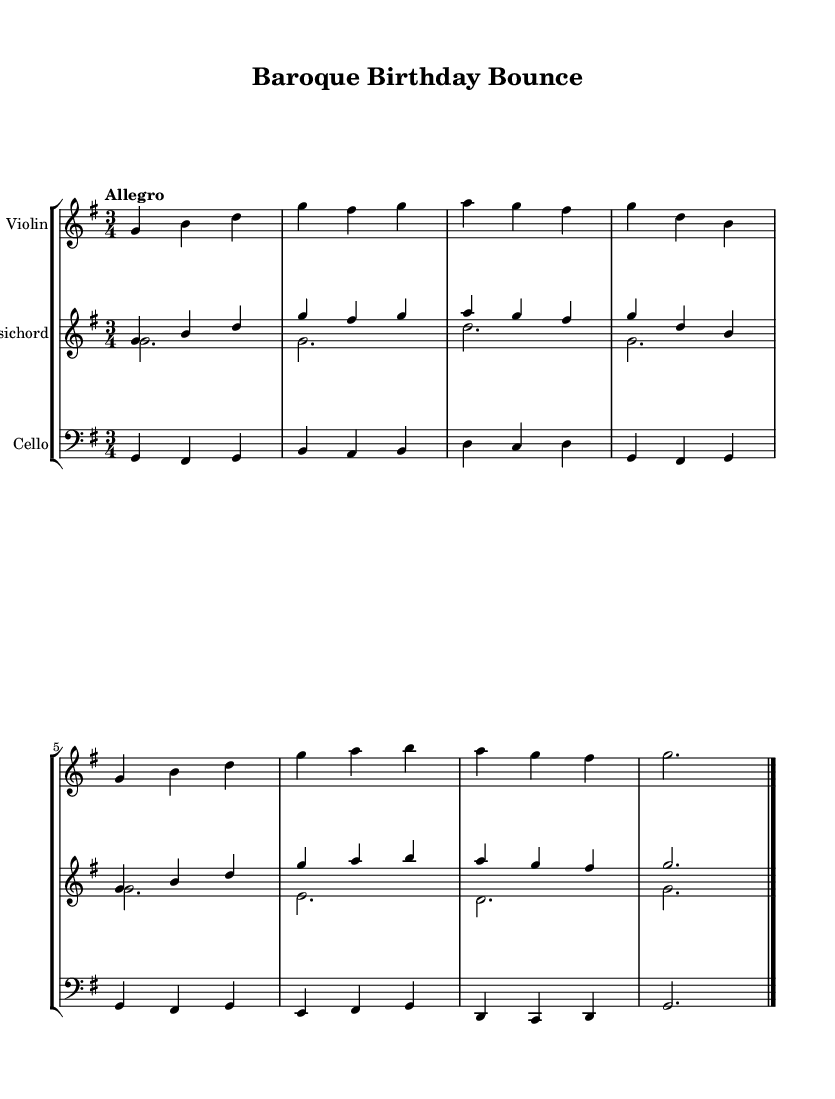What is the key signature of this music? The key signature is G major, which has one sharp (F#). This can be identified by looking at the key signature indicated at the beginning of the staff, which is located between the clef and the time signature.
Answer: G major What is the time signature of this music? The time signature is 3/4, signifying three beats per measure and a quarter note gets one beat. This is evident from the notation written after the key signature at the beginning of the piece.
Answer: 3/4 What is the tempo marking for the music? The tempo marking is "Allegro", suggesting a fast and lively pace. This indication is found near the start of the score, indicating how quickly the music should be played.
Answer: Allegro How many measures are there in the piece? There are eight measures in total. Counting the measures can be done by identifying the vertical lines that denote the end of each measure in the musical notation.
Answer: Eight Which instrument plays the melody? The violin plays the melody. This can be determined by observing that the violin staff is typically higher in pitch and the specific notes arranged for it outline the melodic line.
Answer: Violin What type of dance rhythm is characteristic of this music? The music features an upbeat dance rhythm typical of Baroque dance forms, specifically in a lively 3/4 time signature. The rhythmic structure and tempo contribute to a bouncy feel, commonly associated with Baroque dances like the minuet or gigue.
Answer: Upbeat dance rhythm What is the lowest instrument in this score? The lowest instrument in this score is the cello, which is indicated by the bass clef notation at the beginning of its staff. The bass clef designates lower pitches, making the cello the deepest sounding instrument here.
Answer: Cello 